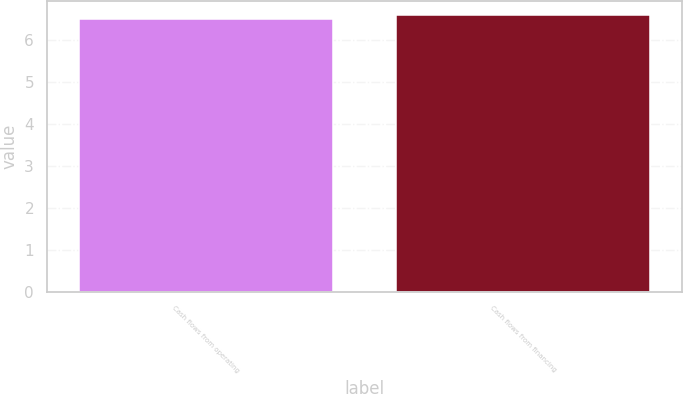Convert chart. <chart><loc_0><loc_0><loc_500><loc_500><bar_chart><fcel>Cash flows from operating<fcel>Cash flows from financing<nl><fcel>6.5<fcel>6.6<nl></chart> 